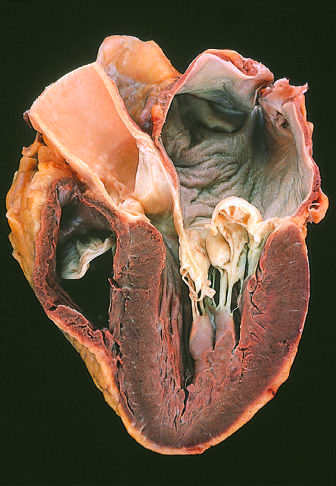what is shown on the right in this four-chamber view?
Answer the question using a single word or phrase. The left ventricle 